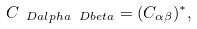<formula> <loc_0><loc_0><loc_500><loc_500>C _ { \ D a l p h a \ D b e t a } = ( C _ { \alpha \beta } ) ^ { * } ,</formula> 